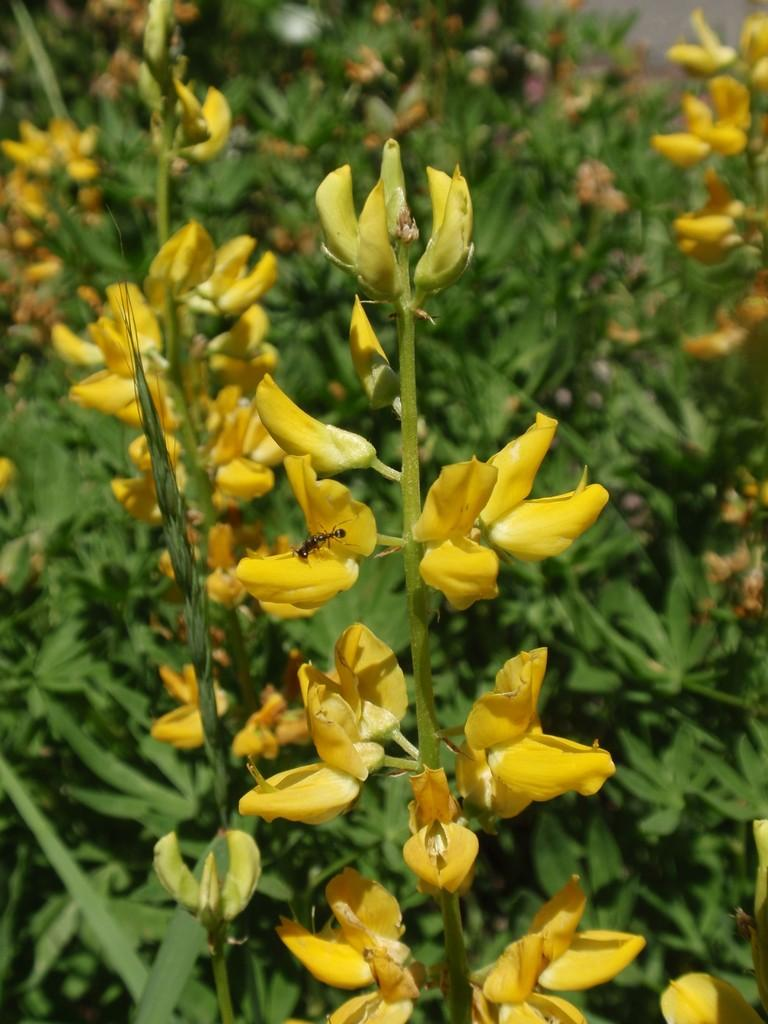What color are the flowers in the image? The flowers in the image are yellow. What stage of growth are the plants in the image? The plants in the image have buds. Can you identify any small creatures in the image? Yes, there appears to be an ant in the image. What type of ink is being used to write on the flowers in the image? There is no ink or writing present on the flowers in the image. Can you describe the facial expressions of the flowers in the image? Flowers do not have facial expressions, as they are plants and not living beings with faces. 